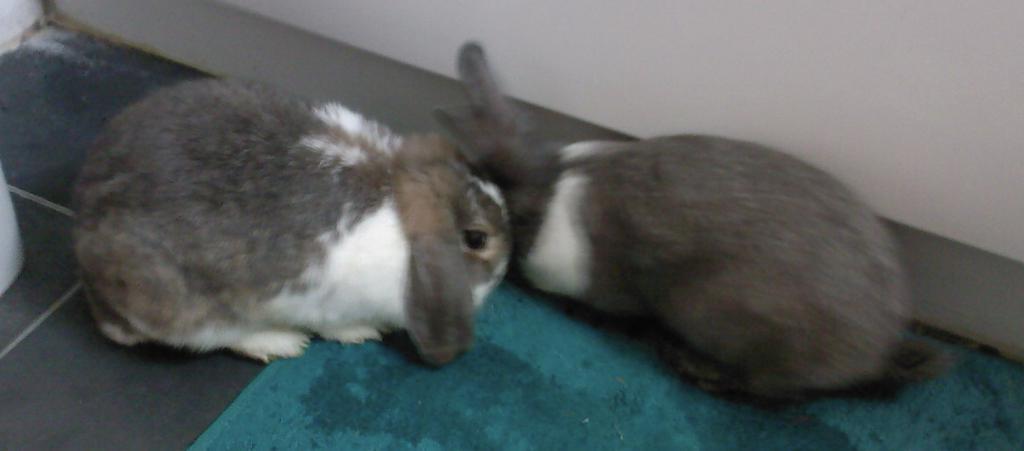Please provide a concise description of this image. In this image I can see two animals, they are in gray and white color. In front I can see the cloth in green color, background the wall is in white color. 